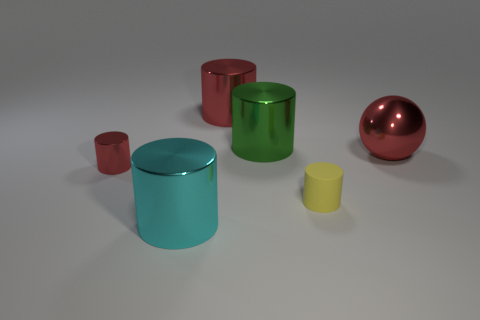There is a tiny cylinder that is the same color as the big metallic ball; what is its material?
Your answer should be compact. Metal. Are there any other green rubber things that have the same shape as the rubber thing?
Give a very brief answer. No. There is a large shiny sphere; is it the same color as the metal thing left of the cyan object?
Keep it short and to the point. Yes. There is another metallic cylinder that is the same color as the small metallic cylinder; what size is it?
Offer a terse response. Large. Is there another object of the same size as the cyan metal thing?
Offer a terse response. Yes. Is the material of the large green cylinder the same as the small object behind the rubber thing?
Keep it short and to the point. Yes. Is the number of yellow objects greater than the number of red objects?
Your response must be concise. No. What number of cubes are either cyan metal objects or tiny red metallic things?
Provide a short and direct response. 0. What color is the large metallic ball?
Offer a very short reply. Red. There is a red thing behind the metal sphere; is its size the same as the shiny object that is in front of the small yellow object?
Keep it short and to the point. Yes. 